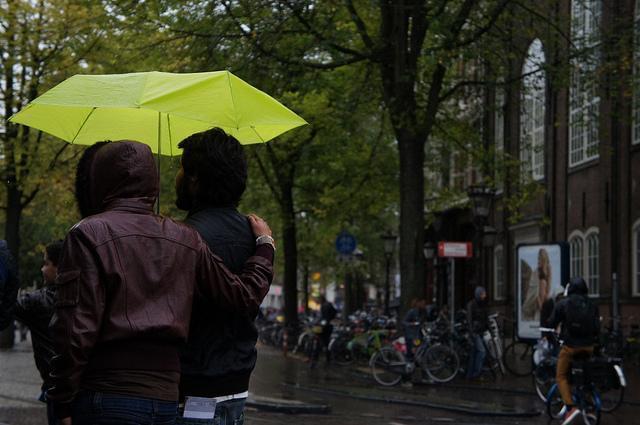Why are they using an umbrella?
Choose the right answer from the provided options to respond to the question.
Options: Disguise, rain, sun, snow. Rain. 